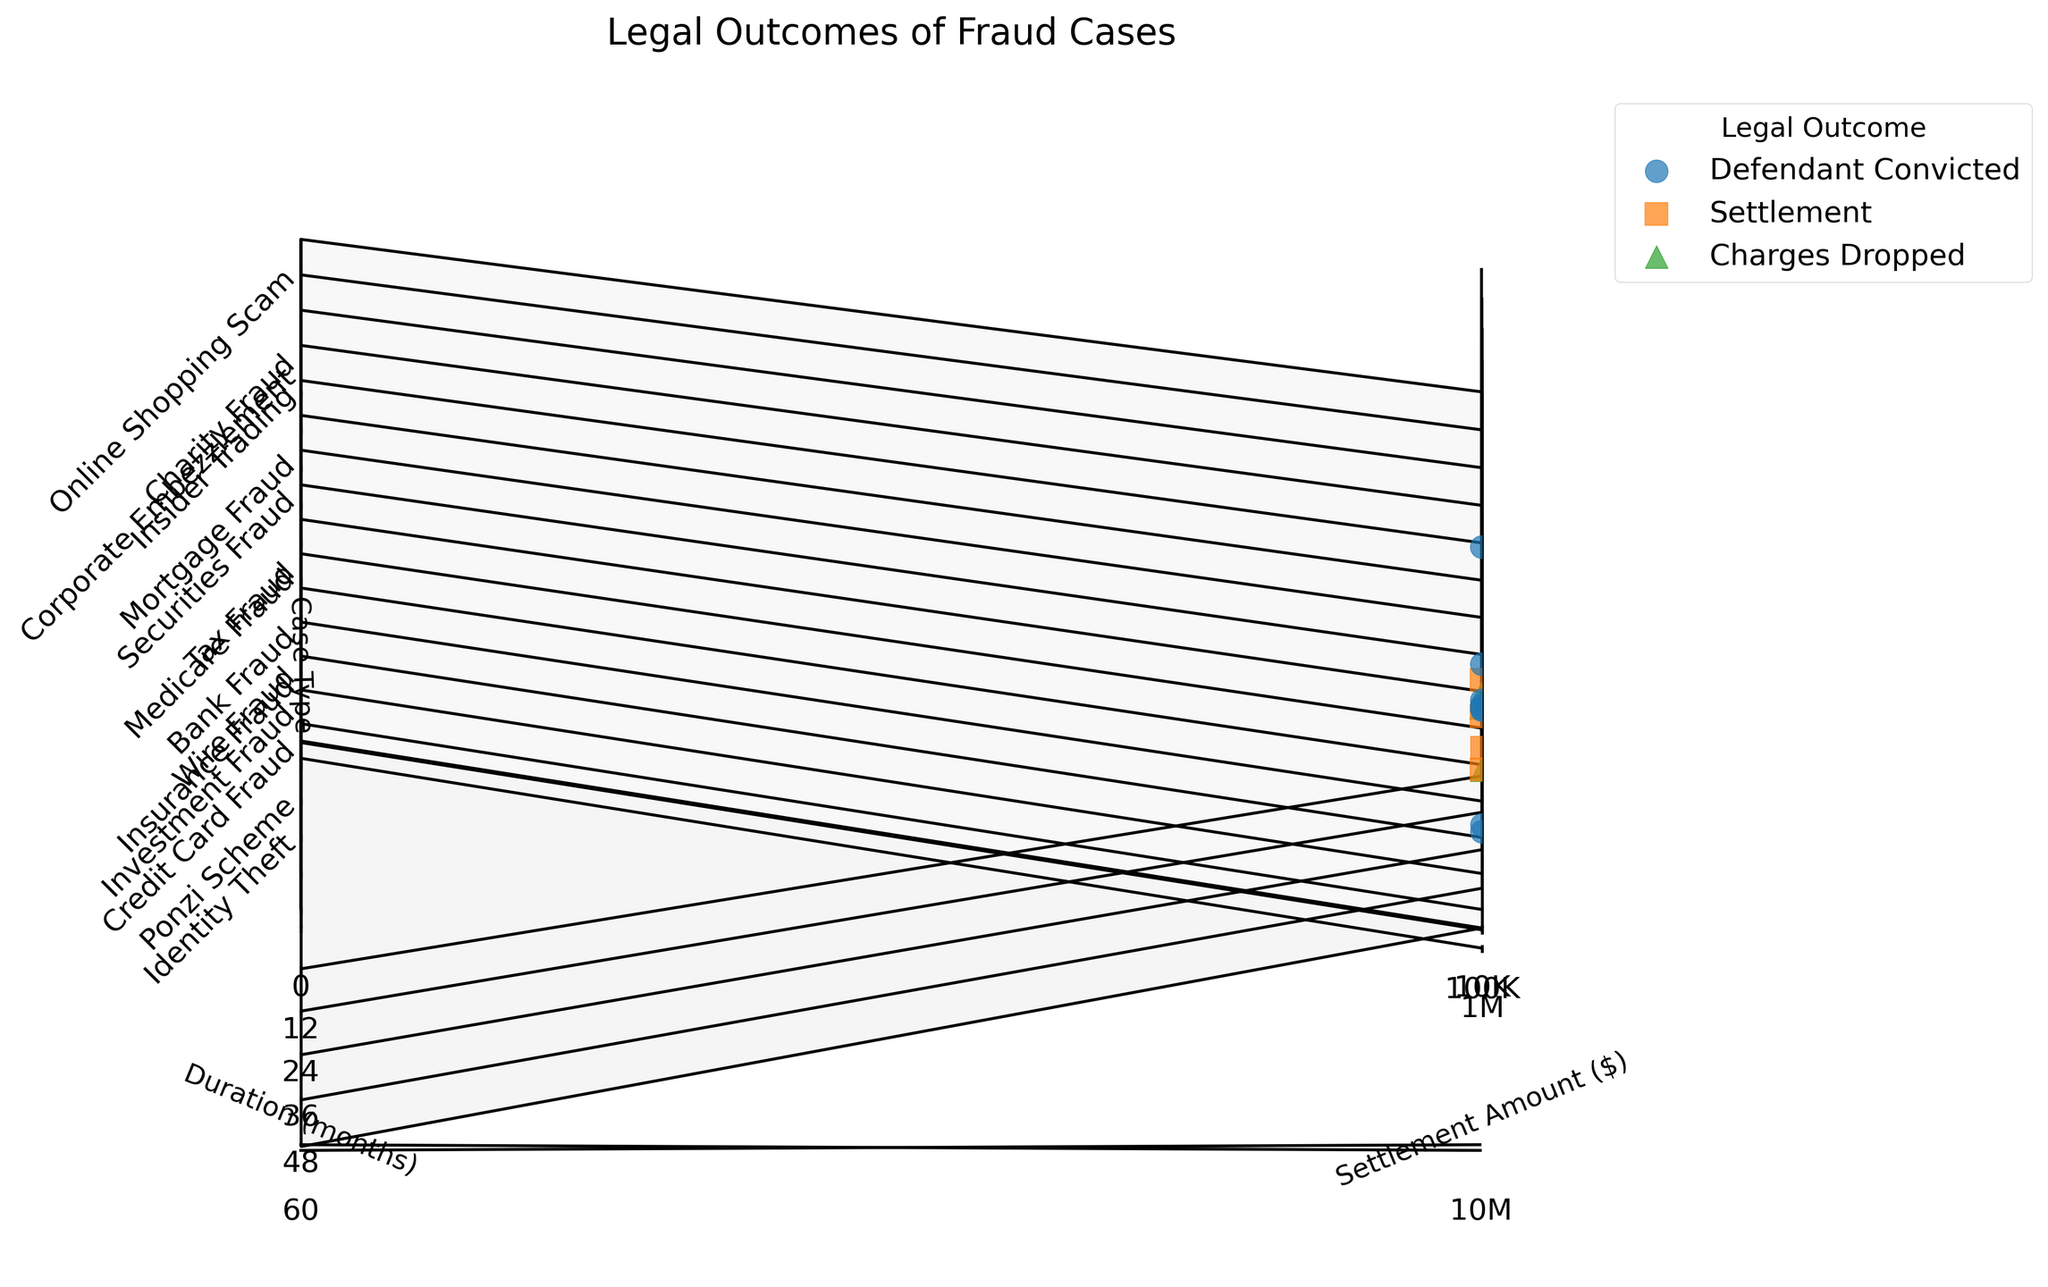what's the title of this plot? The title is written at the top of the plot.
Answer: Legal Outcomes of Fraud Cases what are the labels for the x, y, and z axes? The labels are displayed along each axis. The x-axis is 'Settlement Amount ($)', the y-axis is 'Duration (months)', and the z-axis is 'Case Type'.
Answer: x: Settlement Amount ($), y: Duration (months), z: Case Type how many different legal outcomes are displayed? The legend lists the distinct categories of legal outcomes, which are represented by different colors and markers.
Answer: Three which case type had the highest settlement amount on the plot? By examining the highest point on the x-axis labeled 'Settlement Amount ($)', we see that this corresponds to 'Securities Fraud'.
Answer: Securities Fraud how many data points are associated with the 'Settlement' outcome? The legend indicates the marker for settlements, and by counting these markers, we identify three such points.
Answer: Three what's the duration for the case with the lowest settlement amount? The lowest settlement amount is indicated at the smallest x-axis value, which is linked to 'Online Shopping Scam' lasting 6 months.
Answer: 6 months which case types resulted in 'Charges Dropped'? The z-axis reveals different case types. Points labeled with 'Charges Dropped' are identified using the color and marker from the legend. These are 'Insurance Fraud', 'Tax Fraud', and 'Online Shopping Scam'.
Answer: Insurance Fraud, Tax Fraud, Online Shopping Scam which case type with 'Defendant Convicted' had the maximum duration? Referring to the y-axis for the 'Defendant Convicted' outcome, the tallest point represents 'Securities Fraud' at 48 months.
Answer: Securities Fraud what's the median duration for cases with settlements? Identify durations of settlement cases, arrange them (6, 15, 27, 18), and find that the median (middle value) for four numbers is the average of the second and third values (15+18)/2 = 16.5 months.
Answer: 16.5 months 